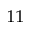<formula> <loc_0><loc_0><loc_500><loc_500>^ { 1 1 }</formula> 